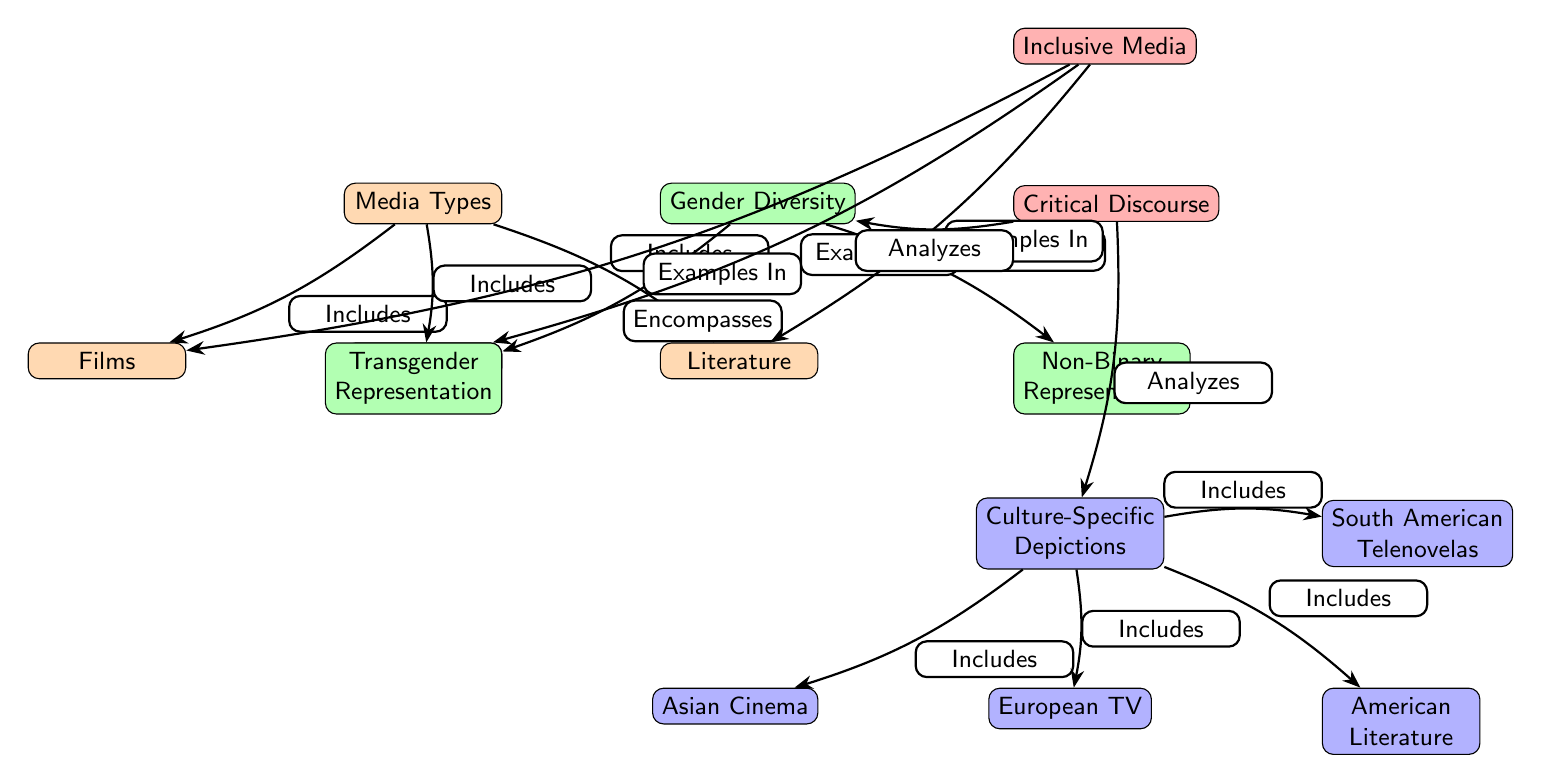What types of media are included in the diagram? The diagram shows three types of media: Films, TV Shows, and Literature. These are depicted as nodes connected to the "Media Types" node with "Includes" relationships.
Answer: Films, TV Shows, Literature How many connections are there from the "Media Types" node? The "Media Types" node has three connections leading to Films, TV Shows, and Literature. Each of these connections represents an inclusion of a specific media type.
Answer: 3 What does the "Gender Diversity" category encompass? The "Gender Diversity" node encompasses two representations: Transgender Representation and Non-Binary Representation. This is shown by the edges labeled "Encompasses" leading to each type.
Answer: Transgender Representation, Non-Binary Representation Which culture-specific media is associated with Asian representation? The "Culture-Specific Depictions" node has a connection to "Asian Cinema." This is depicted as the left child of the Culture node, indicating its association with Asian representation.
Answer: Asian Cinema What do "Inclusive Media" and "Critical Discourse" analyze? "Inclusive Media" analyzes examples in films, TV shows, and literature, while "Critical Discourse" analyzes both gender and culture. The connections indicate the relationship between these analysis forms and their subjects.
Answer: Gender, Culture What is the relationship between "Critical Discourse" and "Gender Diversity"? The relationship is that "Critical Discourse" analyzes "Gender Diversity," demonstrated by a directed edge leading from "Critical Discourse" to "Gender Diversity."
Answer: Analyzes How many types of culture-specific depictions are shown? The diagram shows four types of culture-specific depictions: Asian Cinema, European TV, American Literature, and South American Telenovelas, which are connected to the "Culture-Specific Depictions" node.
Answer: 4 